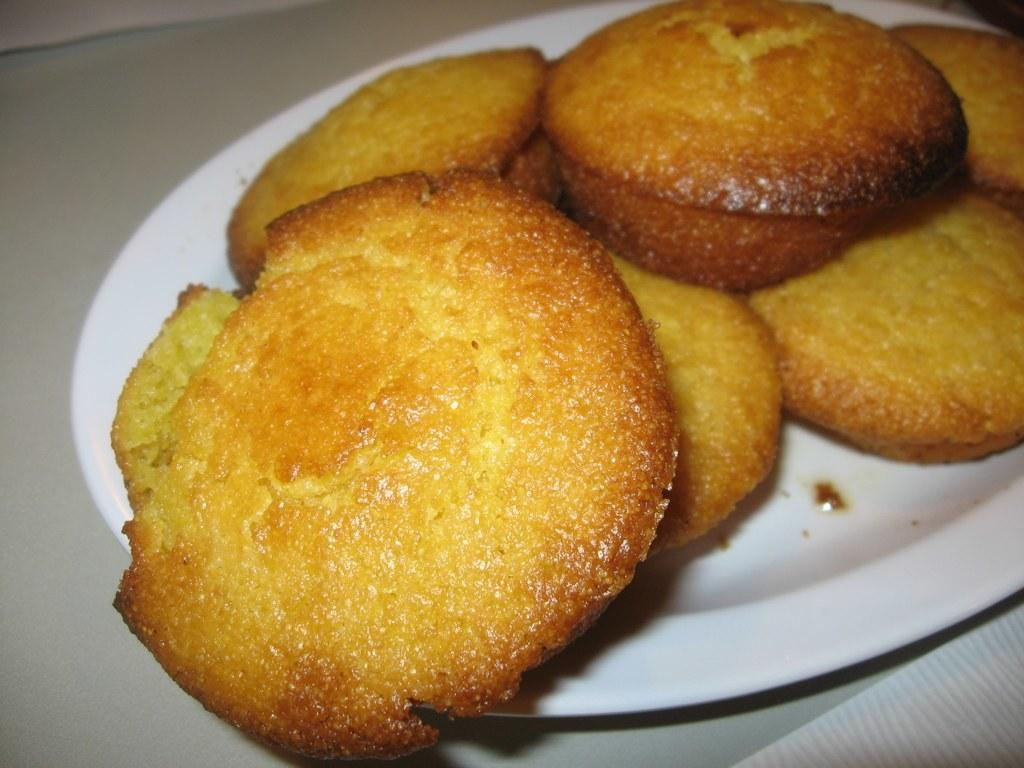What is on the plate that is visible in the image? There is a plate of food items in the image. Where is the plate of food items located? The plate of food items is placed on a table. What type of silver can be seen on the plate in the image? There is no silver present on the plate in the image; it contains food items. How does the ladybug react to the food items on the plate in the image? There is no ladybug present in the image, so it cannot react to the food items. 